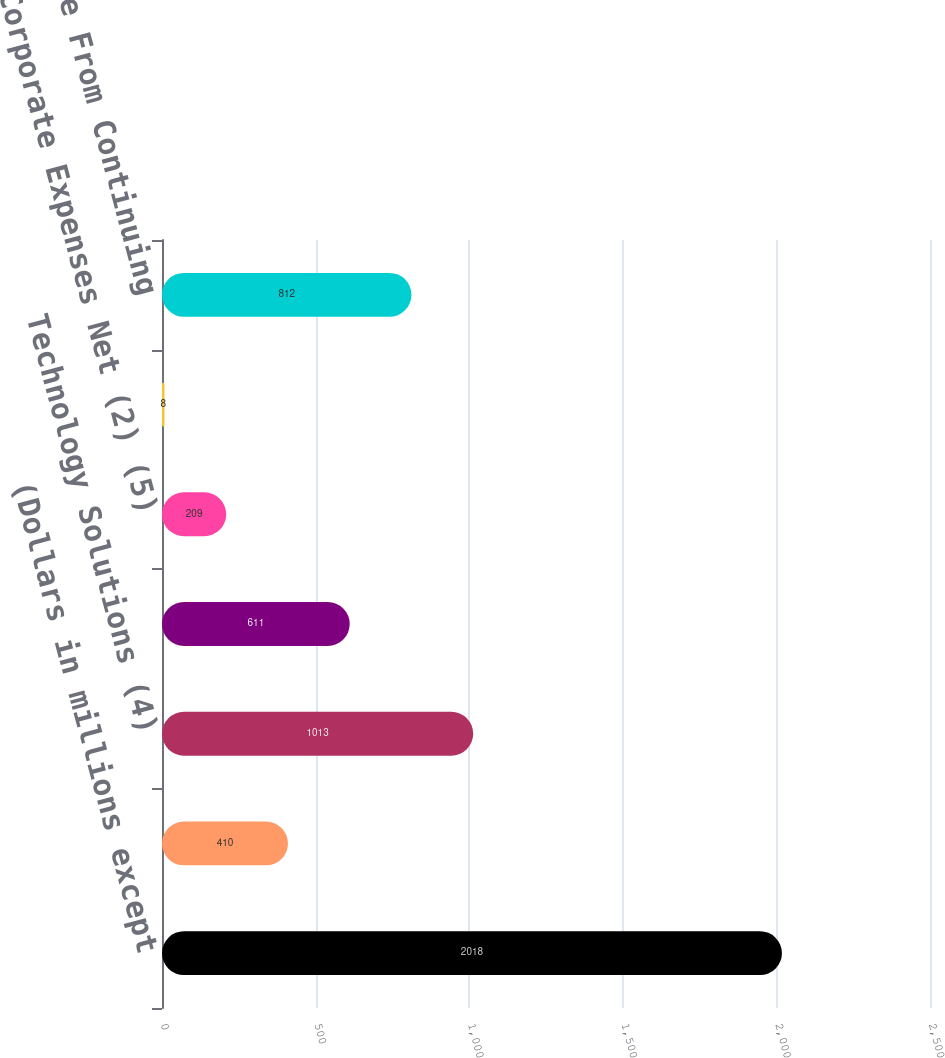Convert chart to OTSL. <chart><loc_0><loc_0><loc_500><loc_500><bar_chart><fcel>(Dollars in millions except<fcel>Distribution Solutions (3)<fcel>Technology Solutions (4)<fcel>Subtotal<fcel>Corporate Expenses Net (2) (5)<fcel>Interest Expense<fcel>Income From Continuing<nl><fcel>2018<fcel>410<fcel>1013<fcel>611<fcel>209<fcel>8<fcel>812<nl></chart> 